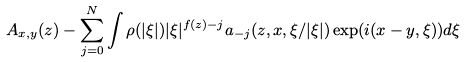Convert formula to latex. <formula><loc_0><loc_0><loc_500><loc_500>A _ { x , y } ( z ) - \sum _ { j = 0 } ^ { N } \int \rho ( | \xi | ) | \xi | ^ { f ( z ) - j } a _ { - j } ( z , x , \xi / | \xi | ) \exp ( i ( x - y , \xi ) ) d \xi</formula> 